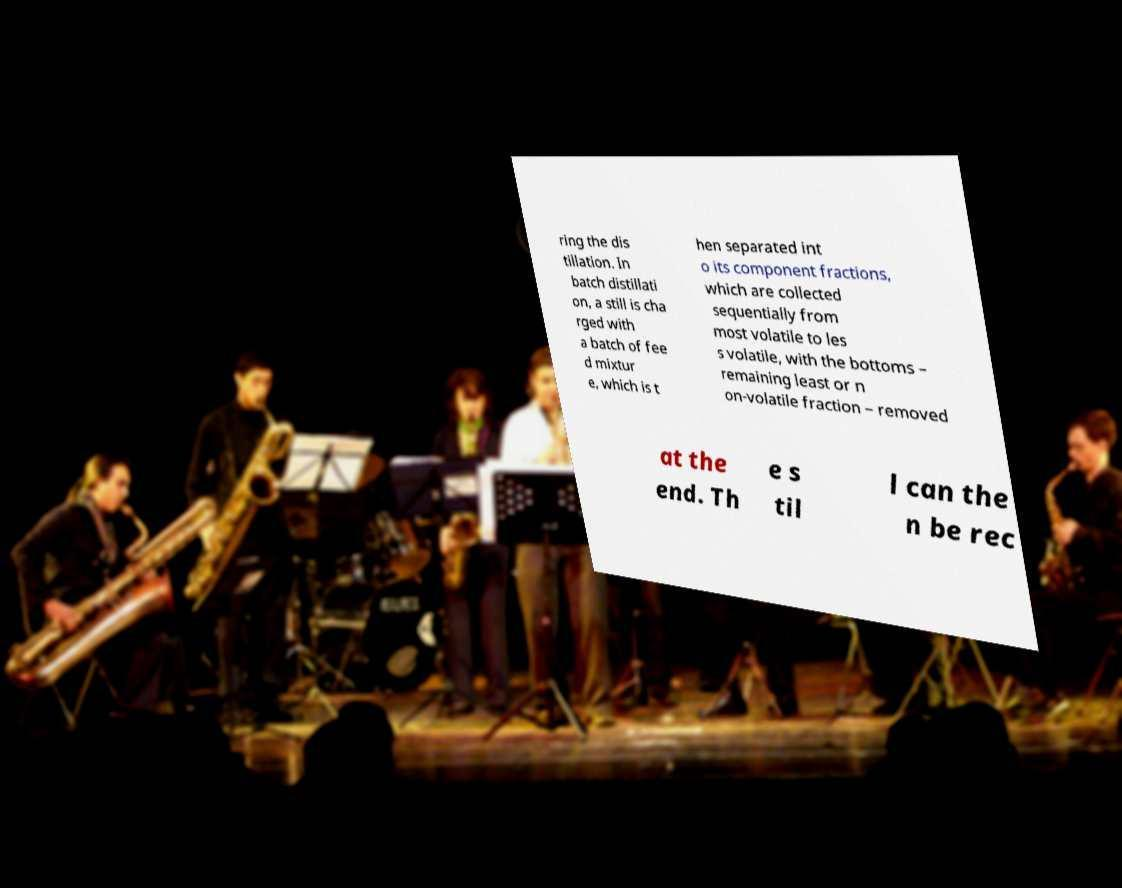There's text embedded in this image that I need extracted. Can you transcribe it verbatim? ring the dis tillation. In batch distillati on, a still is cha rged with a batch of fee d mixtur e, which is t hen separated int o its component fractions, which are collected sequentially from most volatile to les s volatile, with the bottoms – remaining least or n on-volatile fraction – removed at the end. Th e s til l can the n be rec 